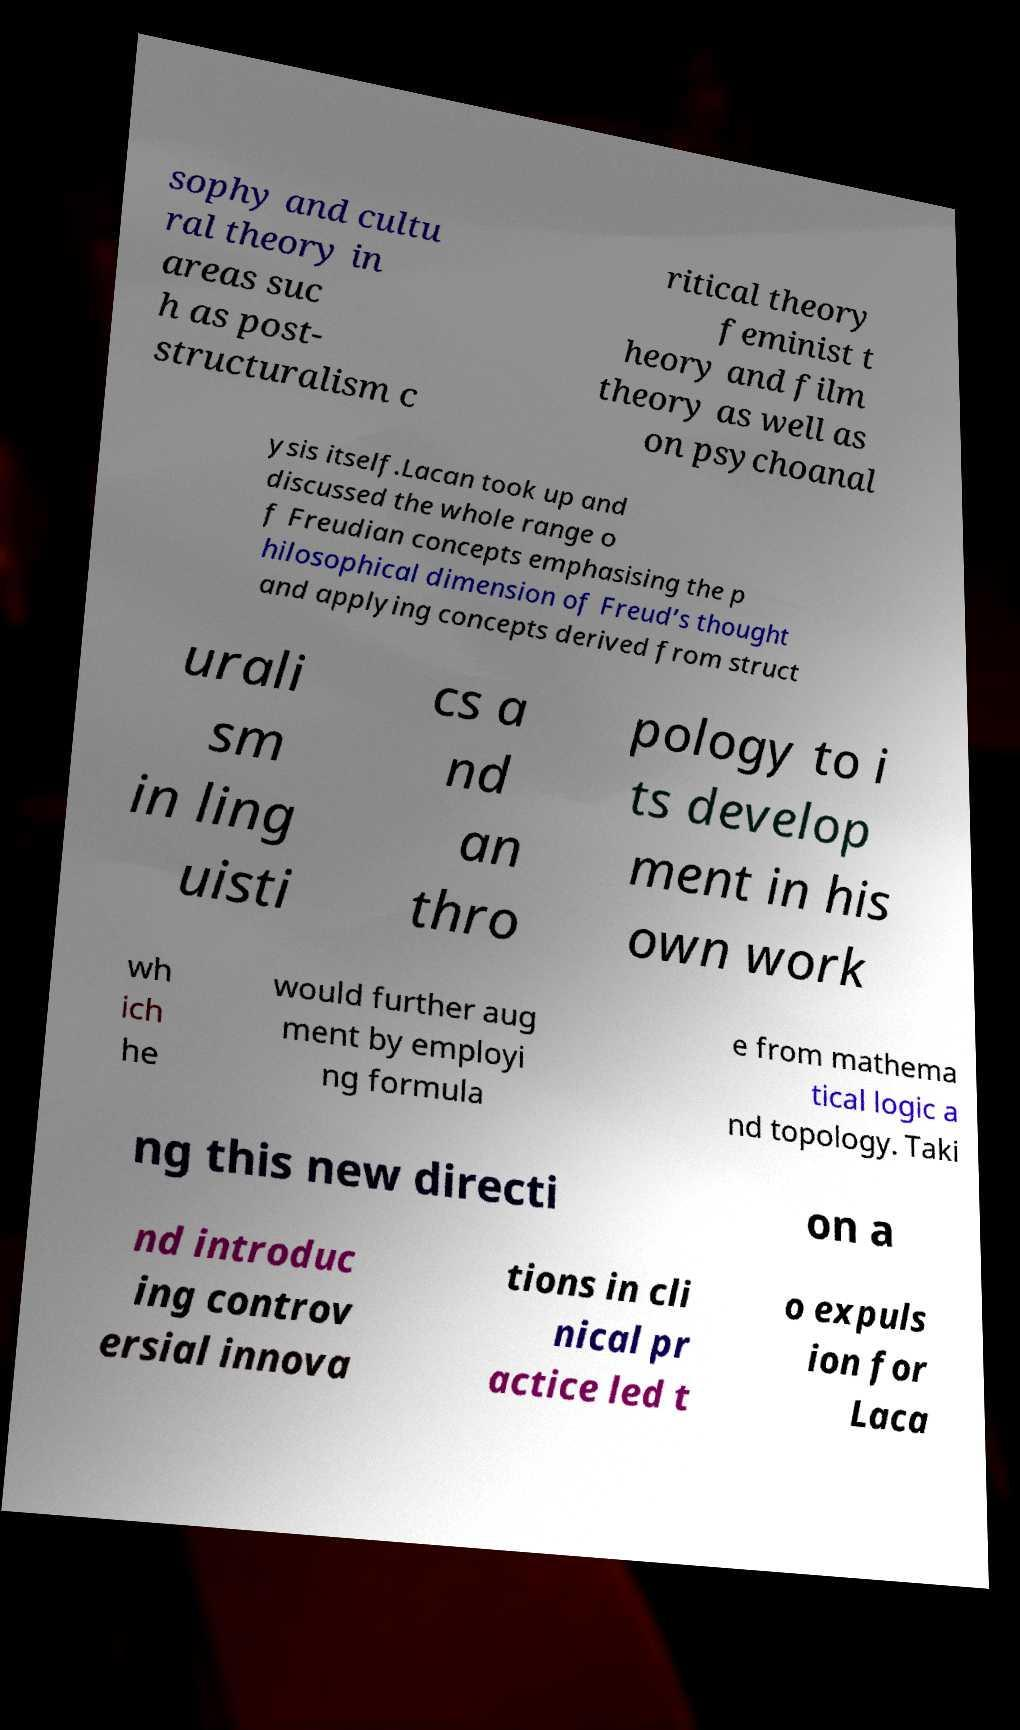For documentation purposes, I need the text within this image transcribed. Could you provide that? sophy and cultu ral theory in areas suc h as post- structuralism c ritical theory feminist t heory and film theory as well as on psychoanal ysis itself.Lacan took up and discussed the whole range o f Freudian concepts emphasising the p hilosophical dimension of Freud’s thought and applying concepts derived from struct urali sm in ling uisti cs a nd an thro pology to i ts develop ment in his own work wh ich he would further aug ment by employi ng formula e from mathema tical logic a nd topology. Taki ng this new directi on a nd introduc ing controv ersial innova tions in cli nical pr actice led t o expuls ion for Laca 